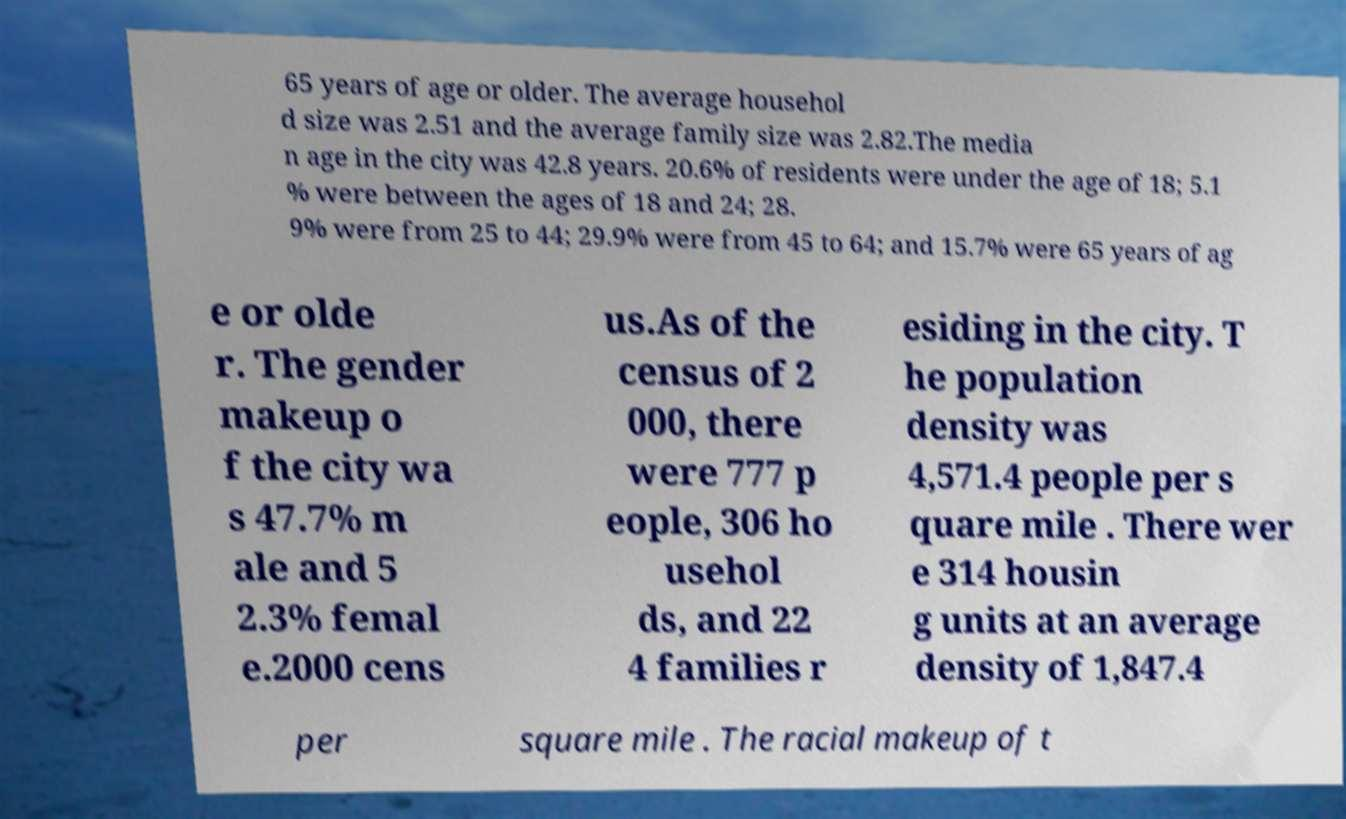Please identify and transcribe the text found in this image. 65 years of age or older. The average househol d size was 2.51 and the average family size was 2.82.The media n age in the city was 42.8 years. 20.6% of residents were under the age of 18; 5.1 % were between the ages of 18 and 24; 28. 9% were from 25 to 44; 29.9% were from 45 to 64; and 15.7% were 65 years of ag e or olde r. The gender makeup o f the city wa s 47.7% m ale and 5 2.3% femal e.2000 cens us.As of the census of 2 000, there were 777 p eople, 306 ho usehol ds, and 22 4 families r esiding in the city. T he population density was 4,571.4 people per s quare mile . There wer e 314 housin g units at an average density of 1,847.4 per square mile . The racial makeup of t 